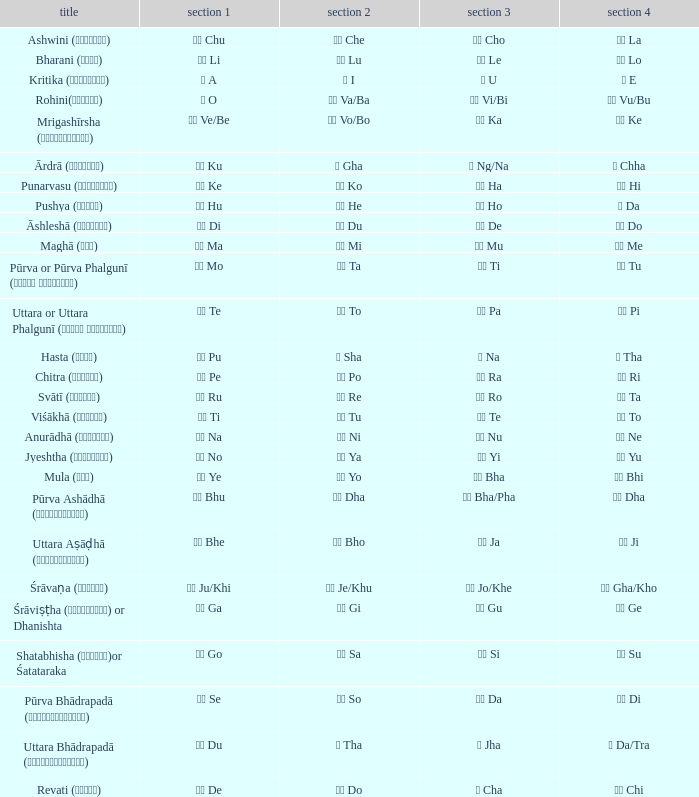What kind of Pada 1 has a Pada 2 of सा sa? गो Go. 